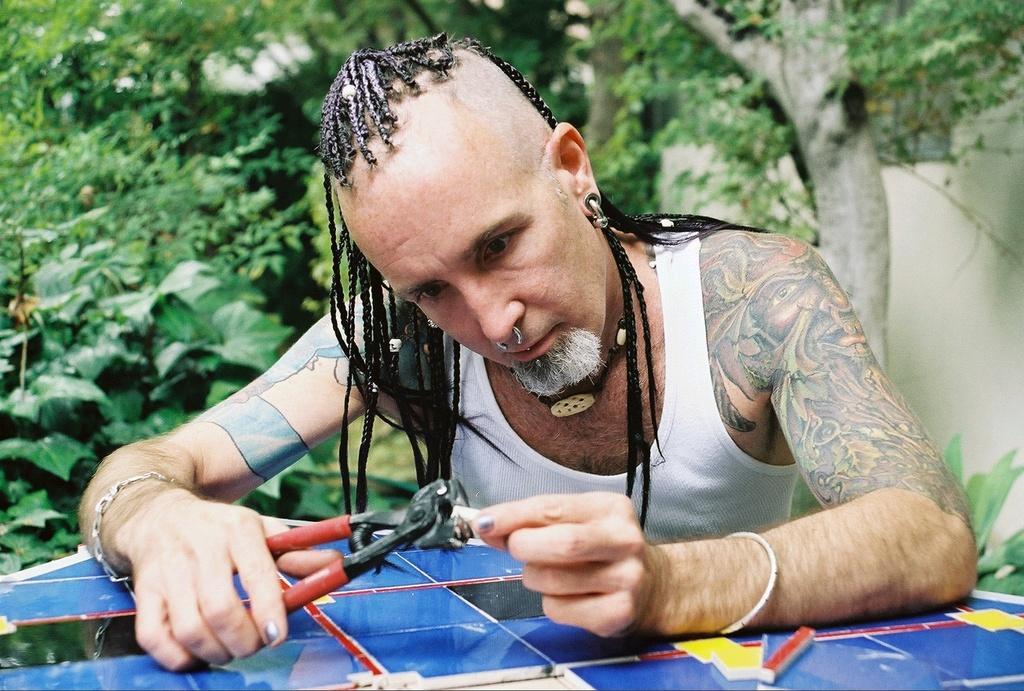Please provide a concise description of this image. In this picture I can see a person holding the cutting pliers. I can see trees in the background. 